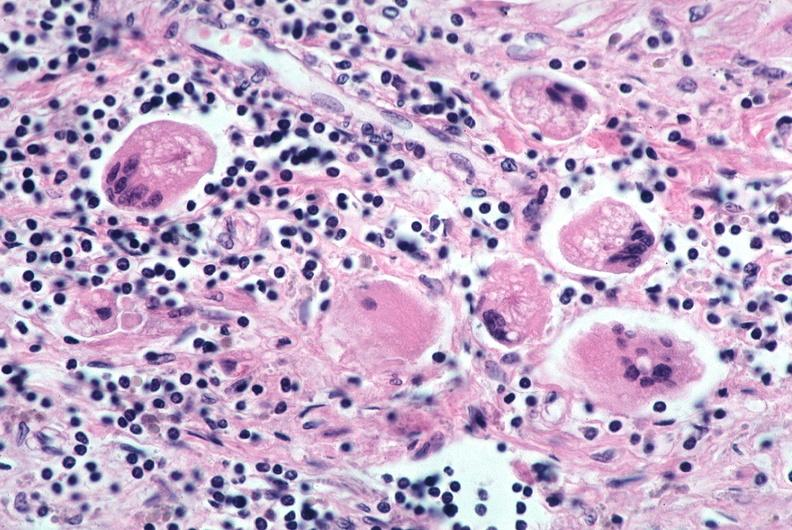where is this?
Answer the question using a single word or phrase. Lung 